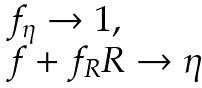<formula> <loc_0><loc_0><loc_500><loc_500>\begin{array} { l r } f _ { \eta } \rightarrow 1 , \\ f + f _ { R } R \rightarrow \eta \end{array}</formula> 